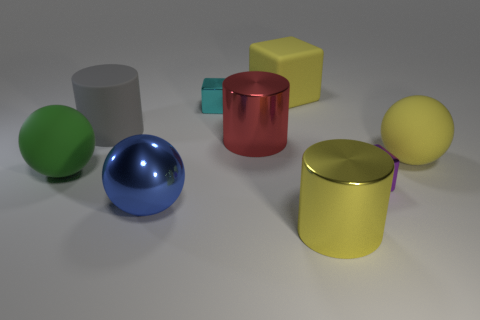Subtract all metallic balls. How many balls are left? 2 Add 1 purple matte blocks. How many objects exist? 10 Subtract all yellow balls. How many balls are left? 2 Subtract 0 gray spheres. How many objects are left? 9 Subtract all spheres. How many objects are left? 6 Subtract 1 cylinders. How many cylinders are left? 2 Subtract all cyan cubes. Subtract all yellow spheres. How many cubes are left? 2 Subtract all blue balls. How many purple cubes are left? 1 Subtract all yellow shiny objects. Subtract all large rubber cylinders. How many objects are left? 7 Add 7 big cylinders. How many big cylinders are left? 10 